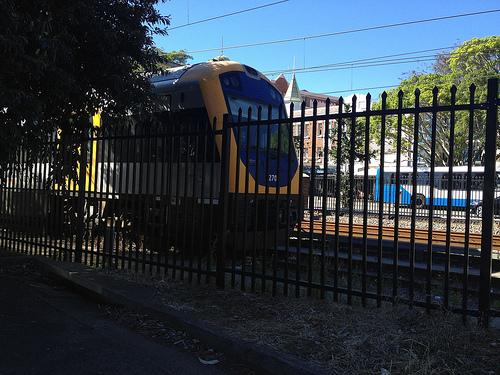Provide a brief description of the background scenery in the image. There are brown and white buildings and a white and blue bus in the background. Describe any infrastructure visible in the image. There are many electrical wires overhead in the photograph. What type of road is visible in the image? A street is visible in the photograph. What is the main transportation mode depicted in the image? The main mode of transportation is a train on tracks. What type of track system is featured in the image? There are train tracks in the photograph. Mention any natural element found in the image. There are many tree leaves in the photograph. Identify the main object in the image and describe its color. The main object is a yellow and grey train on tracks. Describe the fence in the image. There is an iron fence with several visible segments in the photograph. What is the color of the sky in the image? The sky is clear and blue. What feature on the train can be seen clearly in the image? White numbers on the front of the train are clearly visible. 